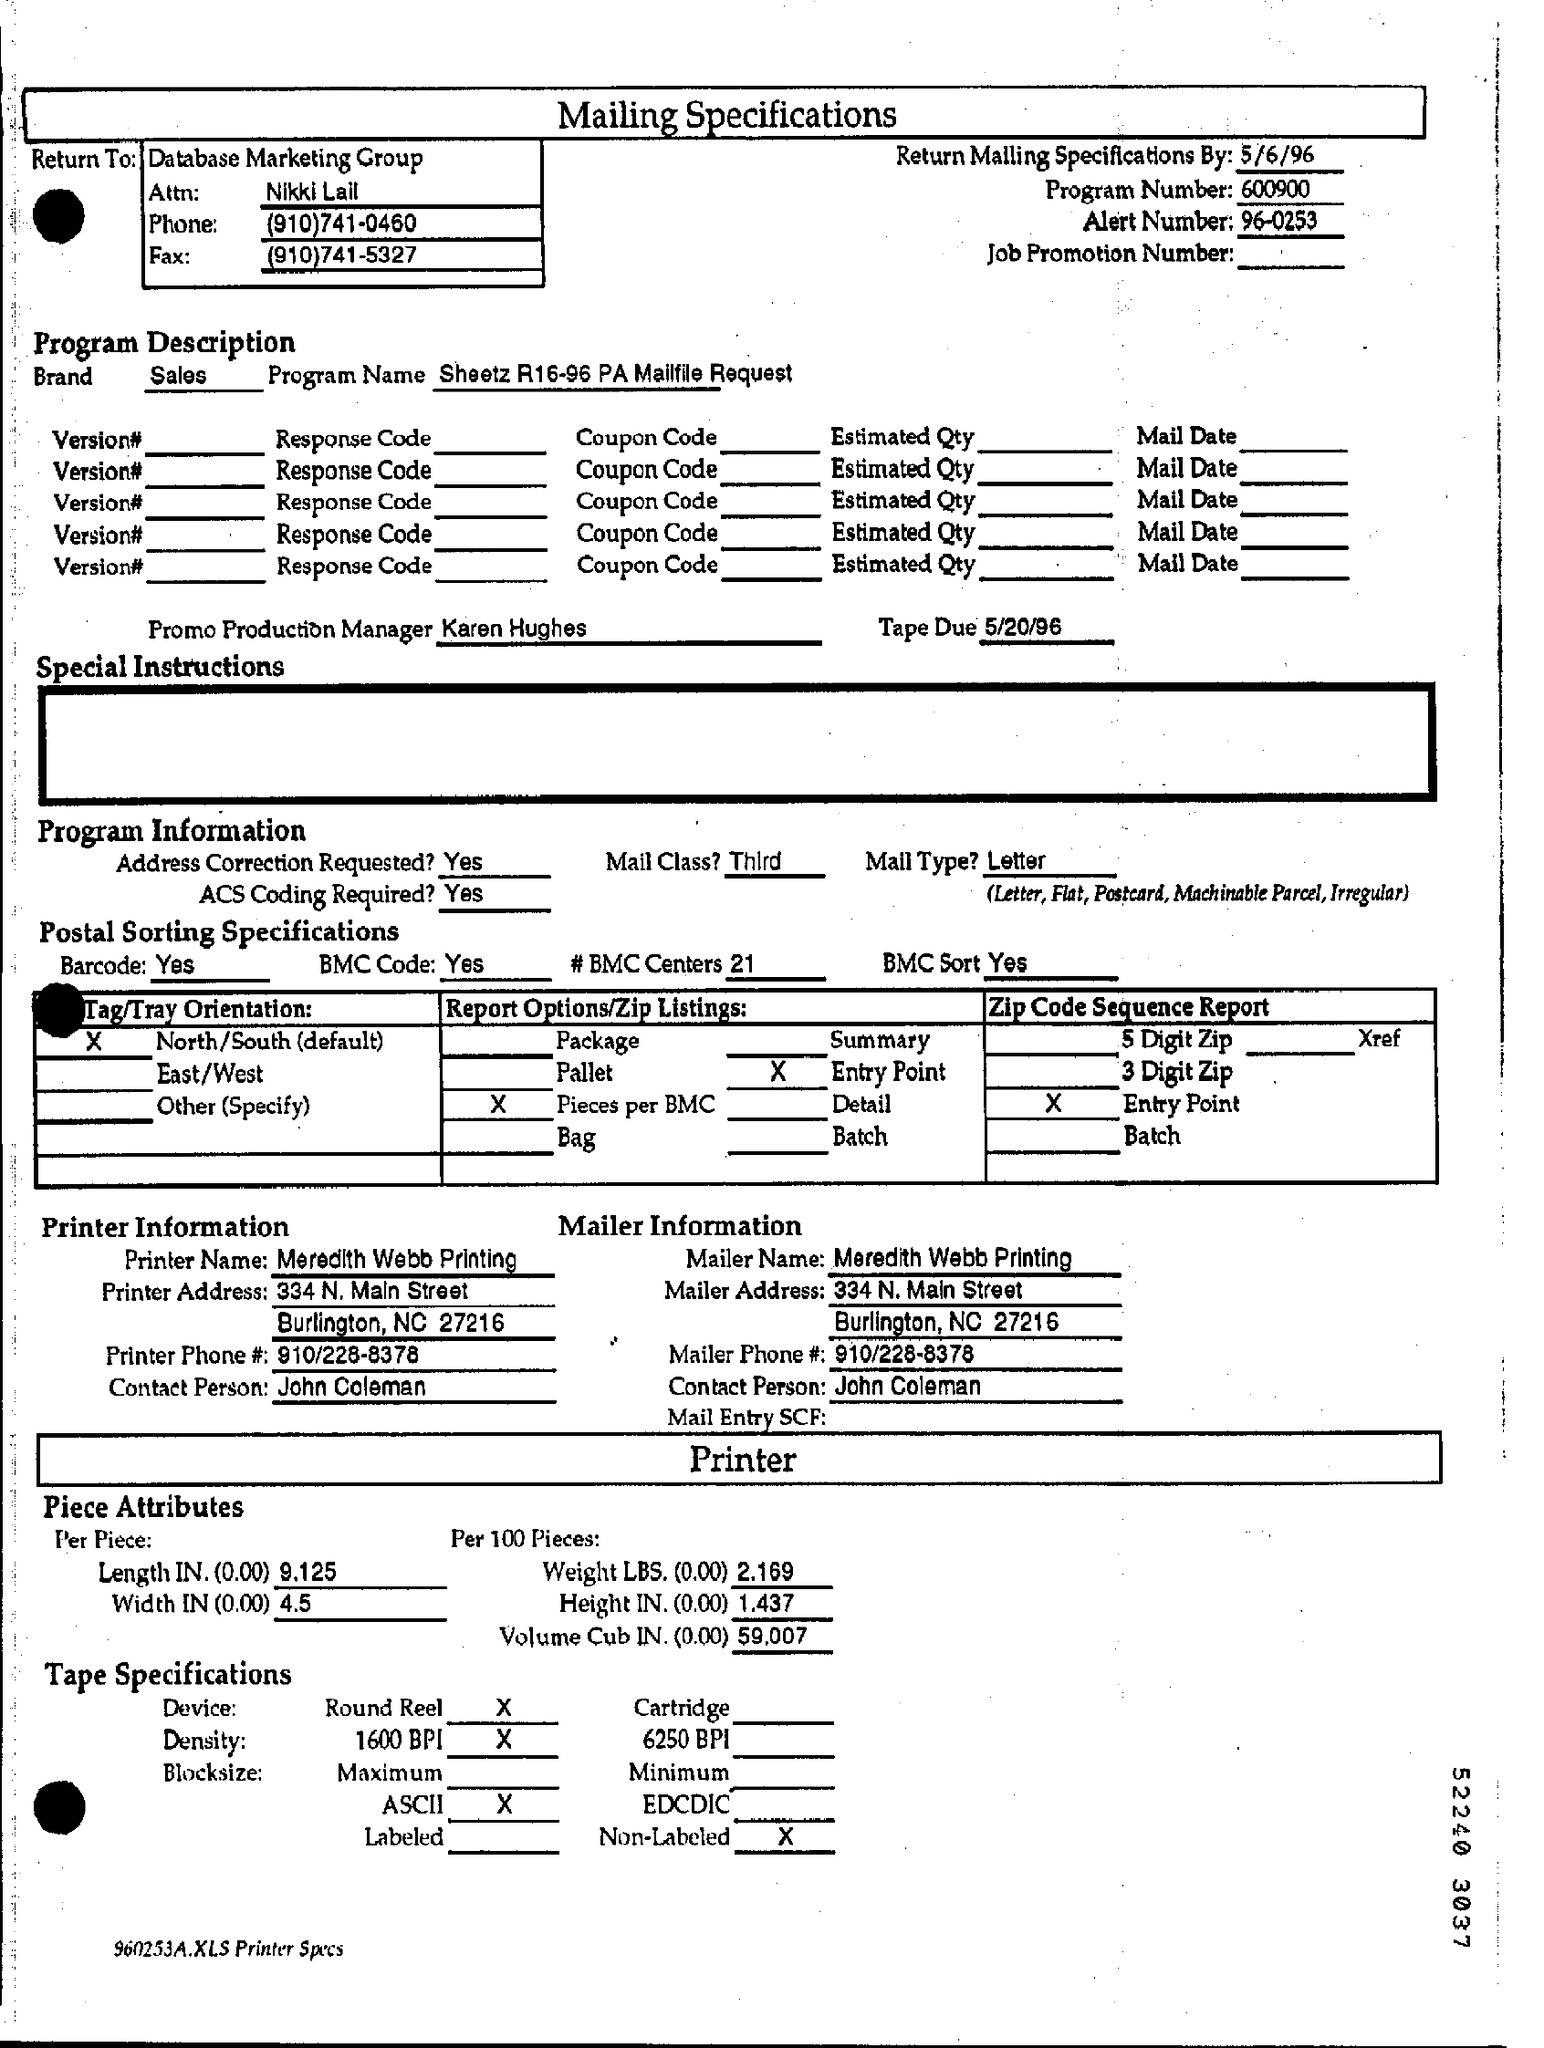What is written in the Letter Head ?
Keep it short and to the point. Mailing specifications. What is the date mentioned in the top of the document ?
Provide a short and direct response. 5/6/96. What is the Program Number ?
Provide a succinct answer. 600900. What is the Alert Number ?
Provide a succinct answer. 96-0253. What is the Fax Number ?
Provide a short and direct response. (910)741-5327. What is the Mailer Name ?
Offer a very short reply. Meredith Webb Printing. What is the Mailer Phone Number ?
Make the answer very short. 910/228-8378. Who is the Promo Production Manager ?
Give a very brief answer. Karen hughes. 